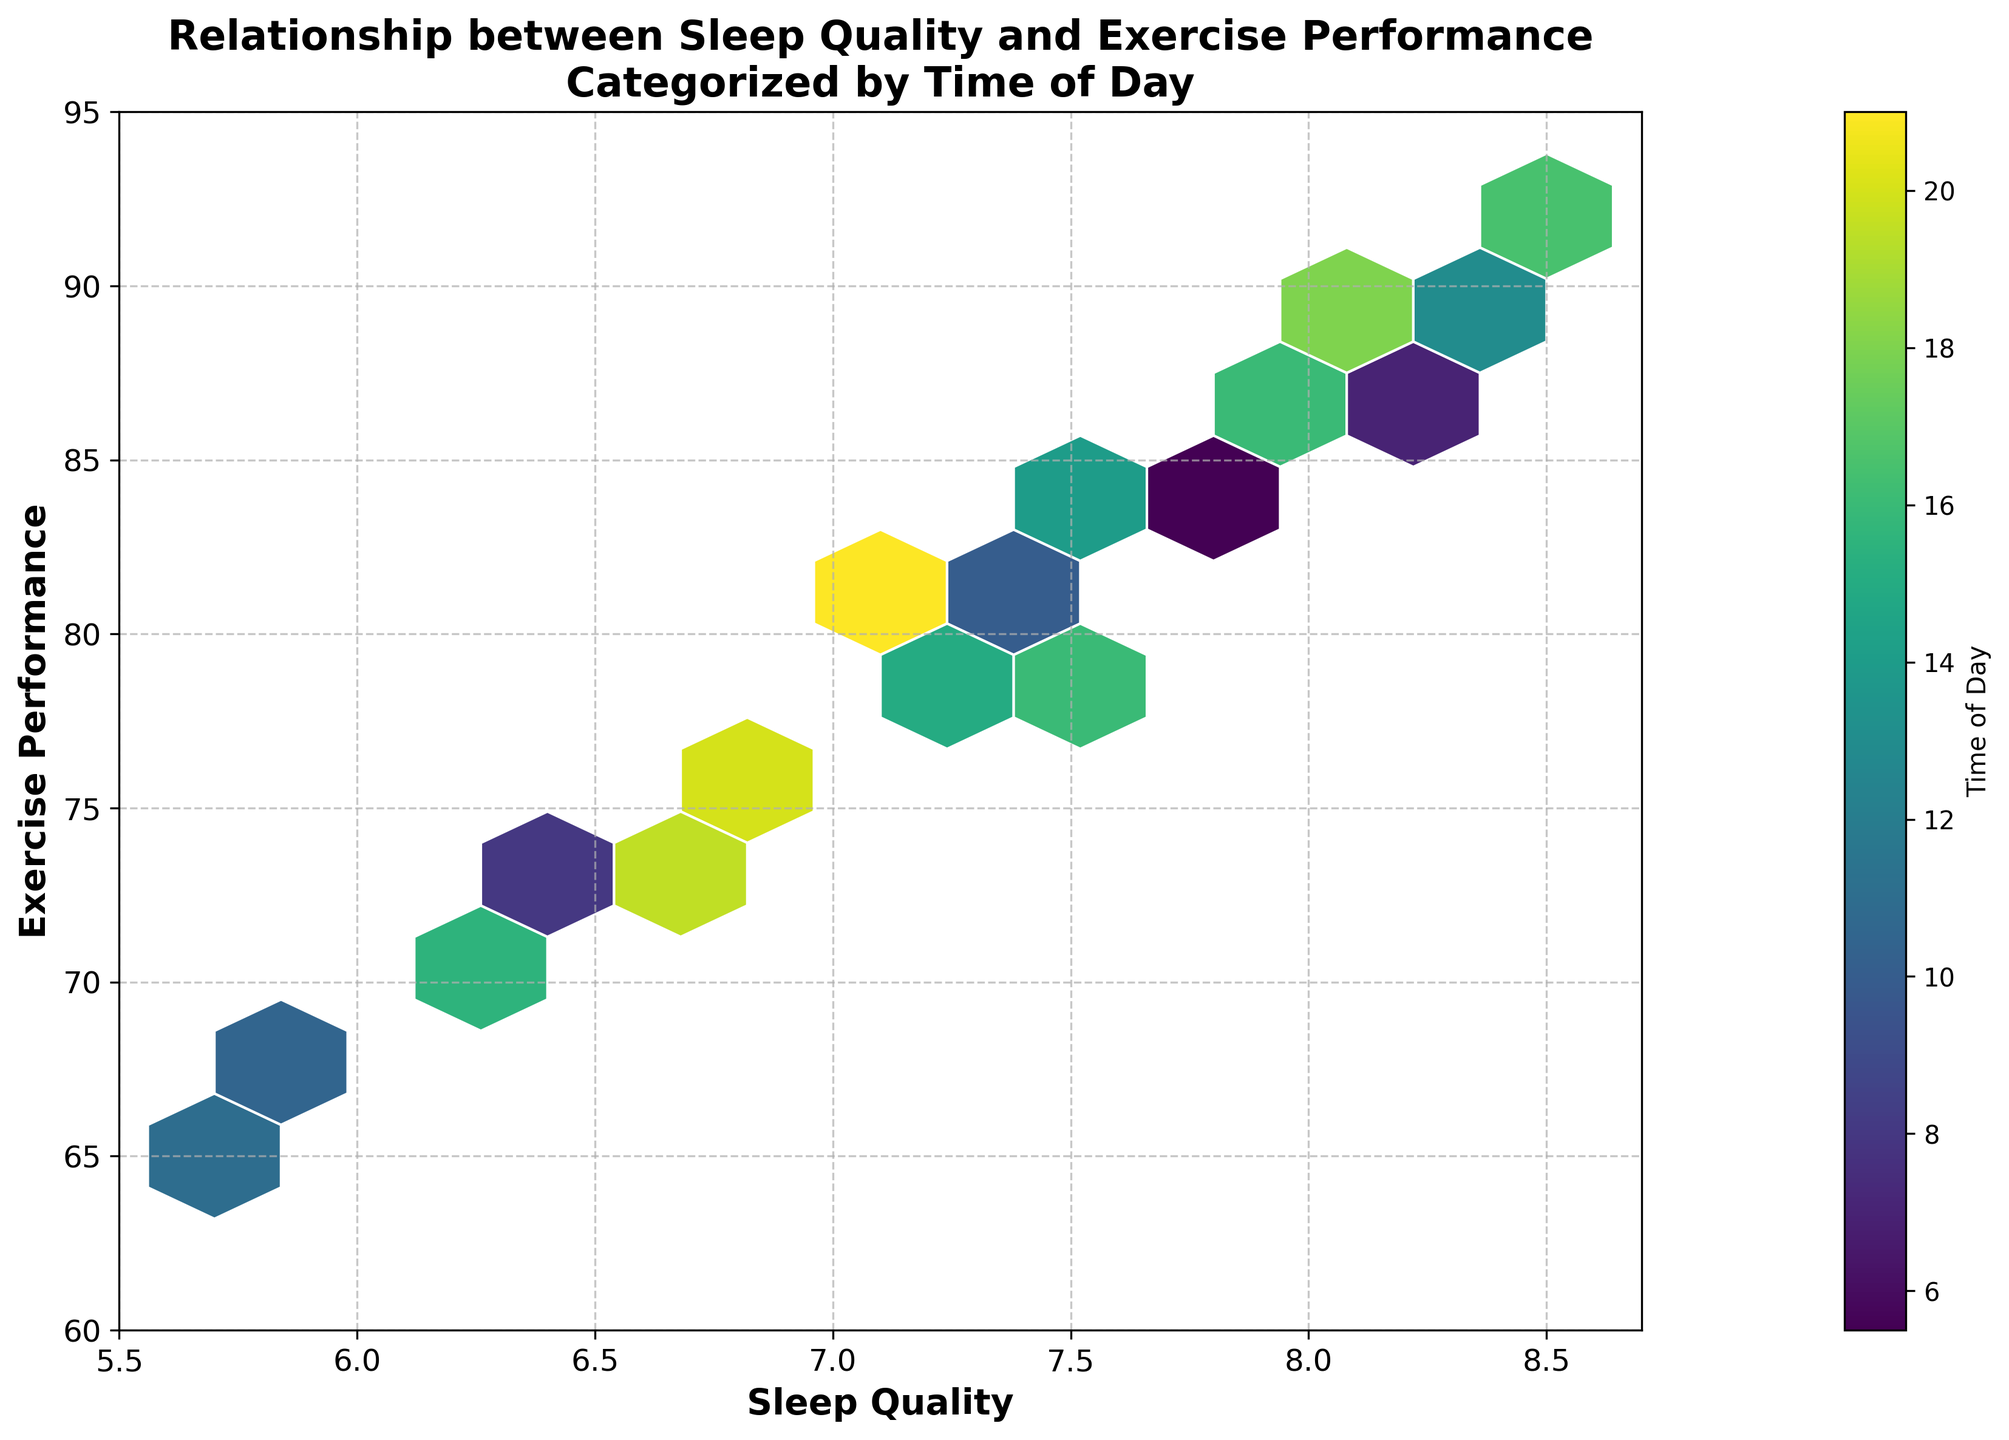What's the title of the hexbin plot? The title is usually located at the top of the plot. Here it reads "Relationship between Sleep Quality and Exercise Performance\nCategorized by Time of Day".
Answer: Relationship between Sleep Quality and Exercise Performance Categorized by Time of Day What's the range of Sleep Quality values shown on the x-axis? The x-axis labels the Sleep Quality values and shows the range from 5.5 to 8.7.
Answer: 5.5 to 8.7 What does the color gradient represent in the hexbin plot? The color gradient in the hexbin plot indicates the Time of Day, as denoted by the colorbar labeled "Time of Day".
Answer: Time of Day What's the median value of Exercise Performance for Sleep Quality values between 7.0 and 7.5 in the morning (before 12 pm)? Identify hexagonal bins that represent Sleep Quality values between 7.0 and 7.5 and Time of Day before 12 pm. The median performance scores from the selected bins need to be found. If the bin values were 79, 82, and 84 from morning times, 82 is the median.
Answer: 82 Is there a noticeable correlation between Sleep Quality and Exercise Performance? Look at the density and distribution of hexagons along the x (Sleep Quality) and y (Exercise Performance) axes. Better sleep quality (higher x values) generally corresponds to higher exercise performance (y values).
Answer: Yes Which time of the day shows the highest density of hexagons for high Sleep Quality and high Exercise Performance? Observe the color gradient (representing Time of Day) in areas of high-density hexagons with high Sleep Quality and high Exercise Performance values. Time periods with darker colors indicate higher density.
Answer: Evening Do participants with Sleep Quality around 8 have consistent Exercise Performance values throughout the day? Check hexagons around Sleep Quality 8 on the x-axis and compare Exercise Performance values across different colors (representing times of day). Values cluster around 85-90 regardless of the time.
Answer: Yes Which time of day shows the lowest Exercise Performance values? Examine the color of hexagons at the lower end of the y-axis (Exercise Performance) to see which Time of Day they represent. Time periods with lighter colors indicate lower performance values.
Answer: Morning How does the density of hexagons vary as Sleep Quality increases from 6 to 8? Observe the distribution and concentration of hexagons as you move from the sleeping quality value of 6 towards 8 on the x-axis. Density increases, indicating better performance with better sleep.
Answer: Increases What is the average Sleep Quality for hexagons where Exercise Performance is greater than 85? Identify hexagons above the 85 Exercise Performance value and estimate the average Sleep Quality of these bins. Average approximately falls between 7.7 and 8.2.
Answer: Around 8 